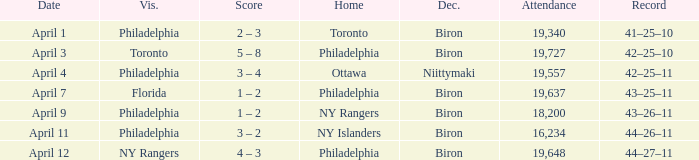What was the flyers' record when the visitors were florida? 43–25–11. Give me the full table as a dictionary. {'header': ['Date', 'Vis.', 'Score', 'Home', 'Dec.', 'Attendance', 'Record'], 'rows': [['April 1', 'Philadelphia', '2 – 3', 'Toronto', 'Biron', '19,340', '41–25–10'], ['April 3', 'Toronto', '5 – 8', 'Philadelphia', 'Biron', '19,727', '42–25–10'], ['April 4', 'Philadelphia', '3 – 4', 'Ottawa', 'Niittymaki', '19,557', '42–25–11'], ['April 7', 'Florida', '1 – 2', 'Philadelphia', 'Biron', '19,637', '43–25–11'], ['April 9', 'Philadelphia', '1 – 2', 'NY Rangers', 'Biron', '18,200', '43–26–11'], ['April 11', 'Philadelphia', '3 – 2', 'NY Islanders', 'Biron', '16,234', '44–26–11'], ['April 12', 'NY Rangers', '4 – 3', 'Philadelphia', 'Biron', '19,648', '44–27–11']]} 